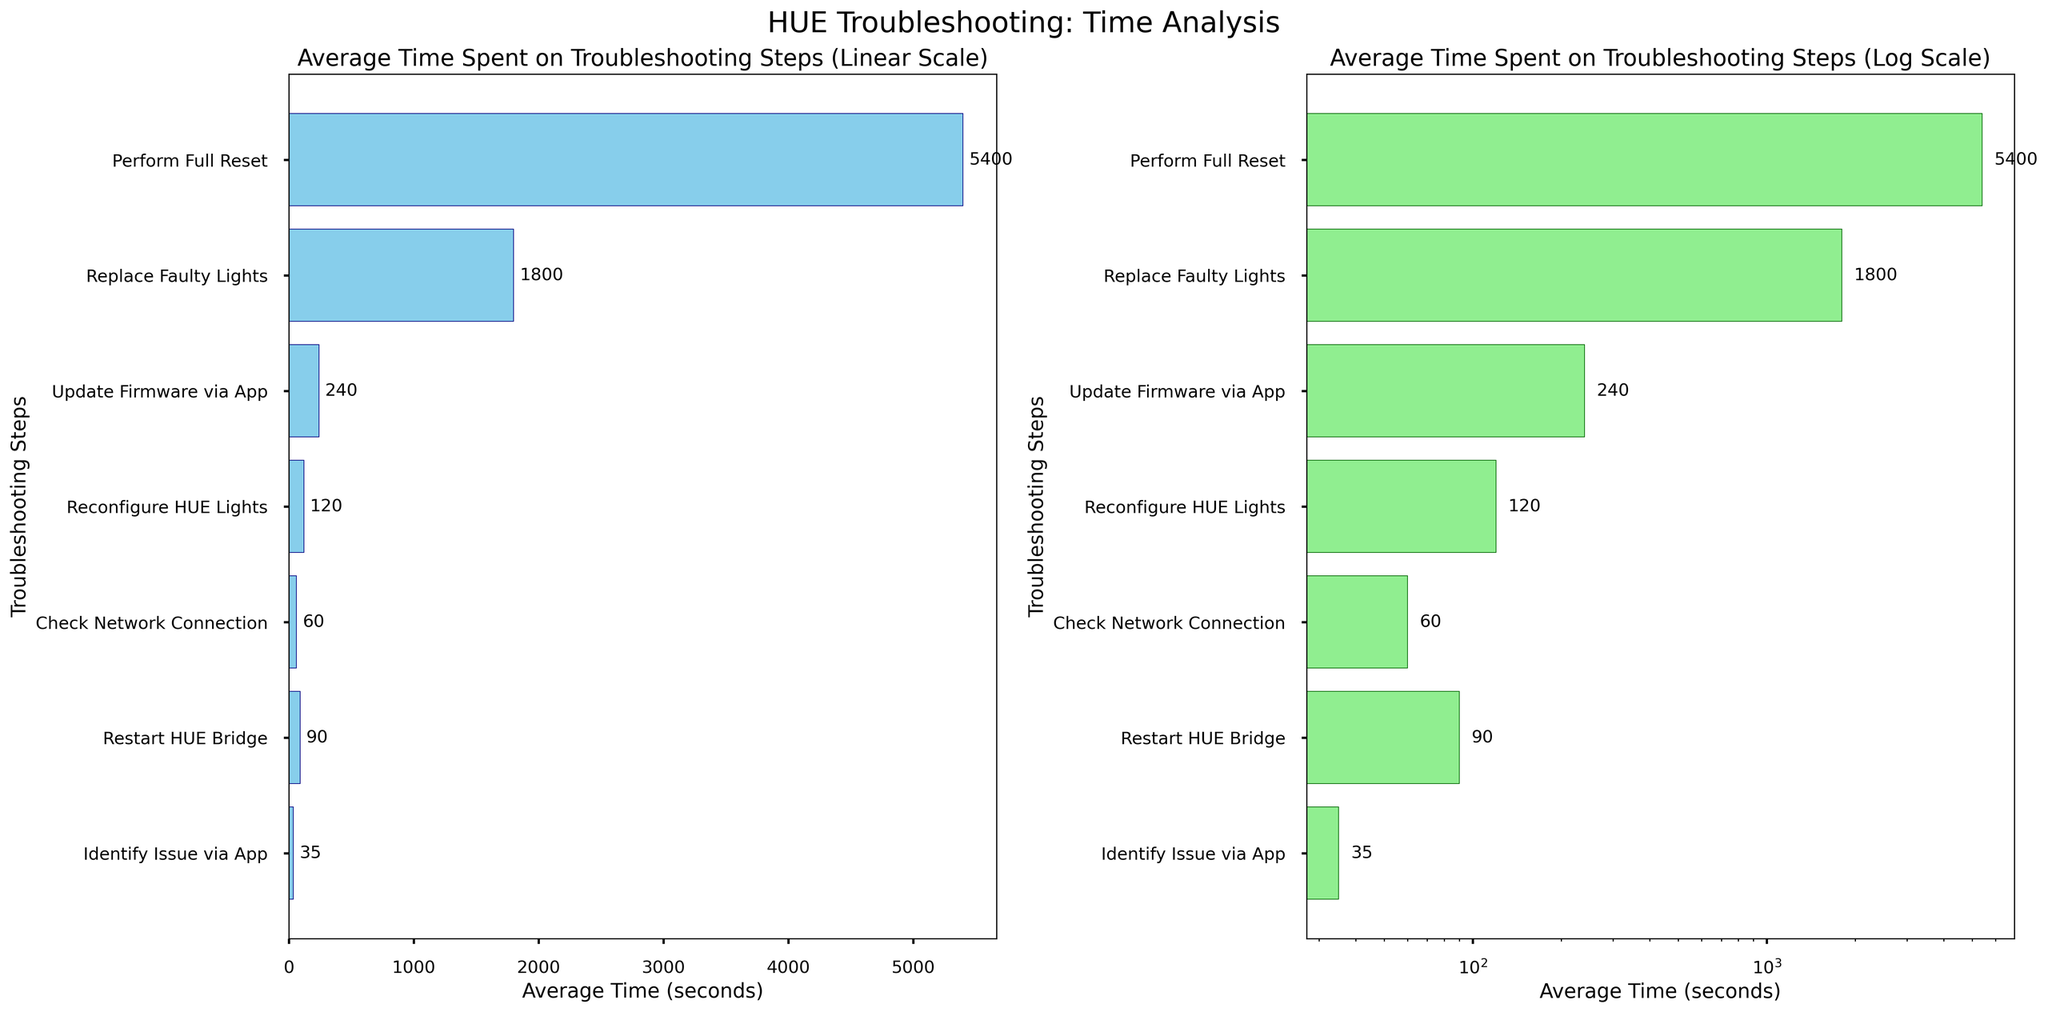What's the title of the left subplot? The left subplot title can be found at the top of the left bar plot. It reads "Average Time Spent on Troubleshooting Steps (Linear Scale)" based on the visual appearance.
Answer: Average Time Spent on Troubleshooting Steps (Linear Scale) What is the longest troubleshooting step in the log scale subplot? In the log scale subplot on the right, the longest bar represents the step "Perform Full Reset". This can be identified by the 5400 seconds label next to this bar.
Answer: Perform Full Reset Which step takes less than 100 seconds to complete in both subplots? By looking at the horizontal bars and their corresponding labels on both subplots, the steps that take less than 100 seconds are "Identify Issue via App" and "Check Network Connection."
Answer: Identify Issue via App, Check Network Connection What is the time difference between "Restart HUE Bridge" and "Replace Faulty Lights"? To find the time difference, look at the time for "Restart HUE Bridge" and "Replace Faulty Lights" on the horizontal axes of both subplots. Subtract 90 seconds (Restart HUE Bridge) from 1800 seconds (Replace Faulty Lights). 1800 - 90 = 1710 seconds.
Answer: 1710 seconds Which step comes directly after "Update Firmware via App" in terms of time spent? In both subplots, "Replace Faulty Lights" is the next longest step after "Update Firmware via App" based on the bar lengths and their positions.
Answer: Replace Faulty Lights How many steps take more than 1000 seconds to complete based on the log scale axis? By looking at the log scale subplot on the right, count the steps with bars extending beyond the 1000-second mark. These steps are "Replace Faulty Lights" and "Perform Full Reset", totaling 2 steps.
Answer: 2 steps What is the shortest average time spent among all troubleshooting steps? The bar that is shortest on both subplots must represent the smallest average time. "Identify Issue via App" has the shortest bar with an average time of 35 seconds as indicated in both subplots.
Answer: 35 seconds Compare the general shape of the two plots. What difference can you observe based on the scaling? In the linear scale plot, longer steps appear more exaggerated, while in the log scale plot, the differences between shorter and longer steps are visually compressed, making it easier to compare multiples of time quantitatively.
Answer: Linear exaggerates differences more, Log compresses them Why might the log scale be useful for interpreting this data? The log scale can be useful for interpreting data with large range differences, as it allows for easier comparison of both small and large values without over-exaggerating larger values as seen in the linear scale. This helps in understanding relative differences better.
Answer: Easier comparison of both small and large values 